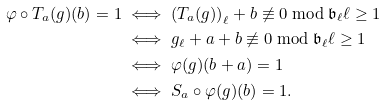<formula> <loc_0><loc_0><loc_500><loc_500>\varphi \circ T _ { a } ( g ) ( b ) = 1 & \iff { ( T _ { a } ( g ) ) } _ { \ell } + b \not \equiv 0 \bmod \mathfrak { b } _ { \ell } \ell \geq 1 \\ & \iff g _ { \ell } + a + b \not \equiv 0 \bmod \mathfrak { b } _ { \ell } \ell \geq 1 \\ & \iff \varphi ( g ) ( b + a ) = 1 \\ & \iff S _ { a } \circ \varphi ( g ) ( b ) = 1 .</formula> 